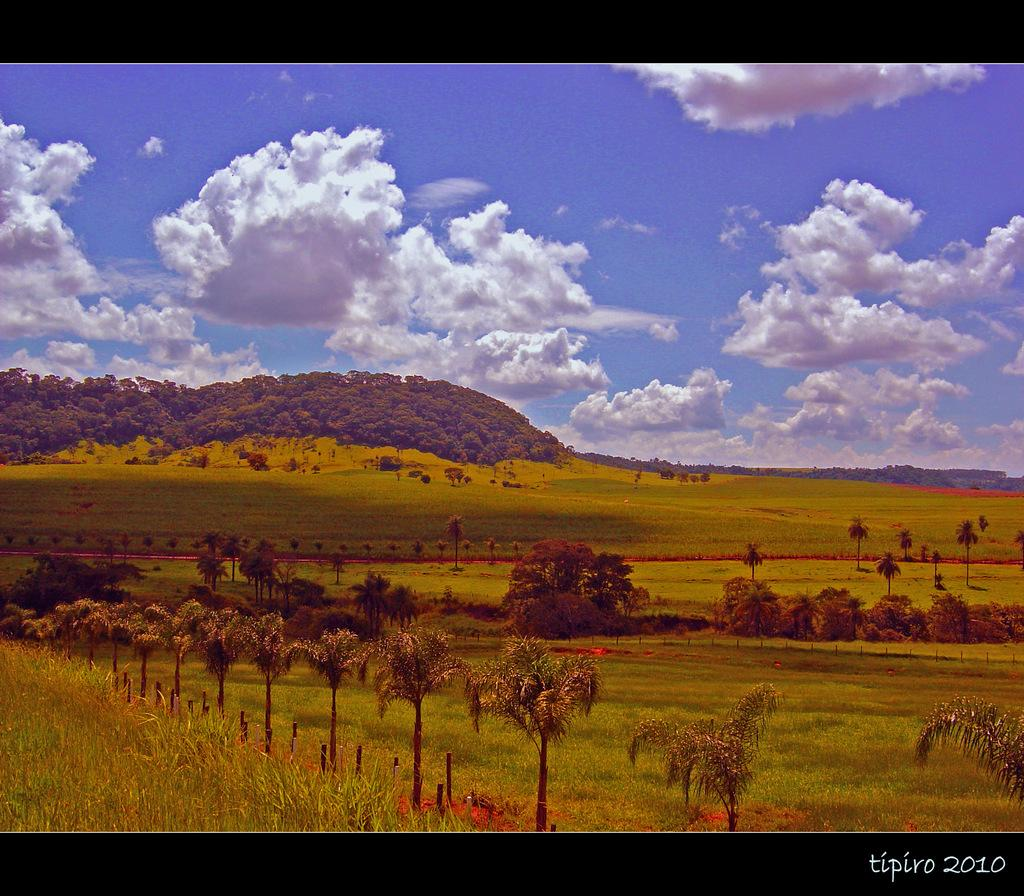What type of terrain is visible in the image? There is an open grass ground in the image. Are there any plants or trees on the grass ground? Yes, there are trees on the grass ground. What can be seen in the background of the image? There are clouds and the sky visible in the background of the image. What is the purpose of the watermark in the image? The purpose of the watermark is not specified in the facts provided. How many people are gathered in the crowd on the grass ground in the image? There is no crowd present in the image; it features an open grass ground with trees. What type of light source is illuminating the grass ground in the image? The facts provided do not mention any light source; the image's lighting is not specified. 